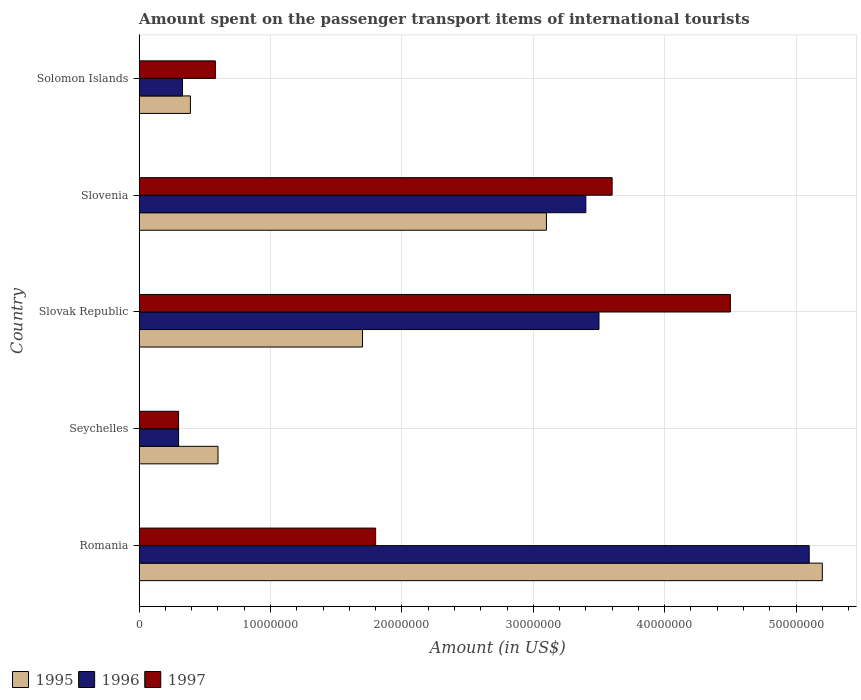How many groups of bars are there?
Offer a terse response. 5. Are the number of bars per tick equal to the number of legend labels?
Your answer should be compact. Yes. Are the number of bars on each tick of the Y-axis equal?
Offer a terse response. Yes. How many bars are there on the 2nd tick from the bottom?
Make the answer very short. 3. What is the label of the 2nd group of bars from the top?
Provide a short and direct response. Slovenia. In how many cases, is the number of bars for a given country not equal to the number of legend labels?
Your answer should be very brief. 0. What is the amount spent on the passenger transport items of international tourists in 1997 in Seychelles?
Ensure brevity in your answer.  3.00e+06. Across all countries, what is the maximum amount spent on the passenger transport items of international tourists in 1996?
Keep it short and to the point. 5.10e+07. Across all countries, what is the minimum amount spent on the passenger transport items of international tourists in 1997?
Ensure brevity in your answer.  3.00e+06. In which country was the amount spent on the passenger transport items of international tourists in 1996 maximum?
Ensure brevity in your answer.  Romania. In which country was the amount spent on the passenger transport items of international tourists in 1995 minimum?
Keep it short and to the point. Solomon Islands. What is the total amount spent on the passenger transport items of international tourists in 1997 in the graph?
Give a very brief answer. 1.08e+08. What is the difference between the amount spent on the passenger transport items of international tourists in 1997 in Slovenia and that in Solomon Islands?
Keep it short and to the point. 3.02e+07. What is the difference between the amount spent on the passenger transport items of international tourists in 1996 in Solomon Islands and the amount spent on the passenger transport items of international tourists in 1997 in Slovenia?
Give a very brief answer. -3.27e+07. What is the average amount spent on the passenger transport items of international tourists in 1997 per country?
Give a very brief answer. 2.16e+07. What is the ratio of the amount spent on the passenger transport items of international tourists in 1995 in Romania to that in Seychelles?
Your answer should be compact. 8.67. Is the difference between the amount spent on the passenger transport items of international tourists in 1997 in Slovak Republic and Slovenia greater than the difference between the amount spent on the passenger transport items of international tourists in 1996 in Slovak Republic and Slovenia?
Your answer should be compact. Yes. What is the difference between the highest and the second highest amount spent on the passenger transport items of international tourists in 1996?
Keep it short and to the point. 1.60e+07. What is the difference between the highest and the lowest amount spent on the passenger transport items of international tourists in 1996?
Provide a succinct answer. 4.80e+07. Is it the case that in every country, the sum of the amount spent on the passenger transport items of international tourists in 1996 and amount spent on the passenger transport items of international tourists in 1995 is greater than the amount spent on the passenger transport items of international tourists in 1997?
Provide a short and direct response. Yes. How many countries are there in the graph?
Offer a very short reply. 5. What is the difference between two consecutive major ticks on the X-axis?
Offer a very short reply. 1.00e+07. Does the graph contain grids?
Keep it short and to the point. Yes. How many legend labels are there?
Your answer should be compact. 3. How are the legend labels stacked?
Your answer should be compact. Horizontal. What is the title of the graph?
Your response must be concise. Amount spent on the passenger transport items of international tourists. What is the Amount (in US$) of 1995 in Romania?
Give a very brief answer. 5.20e+07. What is the Amount (in US$) in 1996 in Romania?
Provide a short and direct response. 5.10e+07. What is the Amount (in US$) of 1997 in Romania?
Your answer should be compact. 1.80e+07. What is the Amount (in US$) of 1997 in Seychelles?
Ensure brevity in your answer.  3.00e+06. What is the Amount (in US$) in 1995 in Slovak Republic?
Make the answer very short. 1.70e+07. What is the Amount (in US$) of 1996 in Slovak Republic?
Provide a succinct answer. 3.50e+07. What is the Amount (in US$) of 1997 in Slovak Republic?
Your answer should be very brief. 4.50e+07. What is the Amount (in US$) of 1995 in Slovenia?
Your answer should be very brief. 3.10e+07. What is the Amount (in US$) of 1996 in Slovenia?
Keep it short and to the point. 3.40e+07. What is the Amount (in US$) of 1997 in Slovenia?
Your answer should be compact. 3.60e+07. What is the Amount (in US$) in 1995 in Solomon Islands?
Provide a short and direct response. 3.90e+06. What is the Amount (in US$) in 1996 in Solomon Islands?
Your response must be concise. 3.30e+06. What is the Amount (in US$) in 1997 in Solomon Islands?
Offer a terse response. 5.80e+06. Across all countries, what is the maximum Amount (in US$) of 1995?
Provide a succinct answer. 5.20e+07. Across all countries, what is the maximum Amount (in US$) in 1996?
Provide a short and direct response. 5.10e+07. Across all countries, what is the maximum Amount (in US$) in 1997?
Your answer should be compact. 4.50e+07. Across all countries, what is the minimum Amount (in US$) in 1995?
Your answer should be compact. 3.90e+06. Across all countries, what is the minimum Amount (in US$) of 1996?
Ensure brevity in your answer.  3.00e+06. Across all countries, what is the minimum Amount (in US$) of 1997?
Offer a very short reply. 3.00e+06. What is the total Amount (in US$) in 1995 in the graph?
Give a very brief answer. 1.10e+08. What is the total Amount (in US$) of 1996 in the graph?
Keep it short and to the point. 1.26e+08. What is the total Amount (in US$) of 1997 in the graph?
Your answer should be compact. 1.08e+08. What is the difference between the Amount (in US$) in 1995 in Romania and that in Seychelles?
Provide a succinct answer. 4.60e+07. What is the difference between the Amount (in US$) of 1996 in Romania and that in Seychelles?
Ensure brevity in your answer.  4.80e+07. What is the difference between the Amount (in US$) in 1997 in Romania and that in Seychelles?
Keep it short and to the point. 1.50e+07. What is the difference between the Amount (in US$) in 1995 in Romania and that in Slovak Republic?
Your answer should be very brief. 3.50e+07. What is the difference between the Amount (in US$) in 1996 in Romania and that in Slovak Republic?
Offer a very short reply. 1.60e+07. What is the difference between the Amount (in US$) of 1997 in Romania and that in Slovak Republic?
Ensure brevity in your answer.  -2.70e+07. What is the difference between the Amount (in US$) of 1995 in Romania and that in Slovenia?
Offer a very short reply. 2.10e+07. What is the difference between the Amount (in US$) of 1996 in Romania and that in Slovenia?
Your answer should be compact. 1.70e+07. What is the difference between the Amount (in US$) of 1997 in Romania and that in Slovenia?
Your response must be concise. -1.80e+07. What is the difference between the Amount (in US$) of 1995 in Romania and that in Solomon Islands?
Your answer should be compact. 4.81e+07. What is the difference between the Amount (in US$) in 1996 in Romania and that in Solomon Islands?
Your answer should be very brief. 4.77e+07. What is the difference between the Amount (in US$) of 1997 in Romania and that in Solomon Islands?
Your answer should be compact. 1.22e+07. What is the difference between the Amount (in US$) in 1995 in Seychelles and that in Slovak Republic?
Your response must be concise. -1.10e+07. What is the difference between the Amount (in US$) in 1996 in Seychelles and that in Slovak Republic?
Your answer should be compact. -3.20e+07. What is the difference between the Amount (in US$) in 1997 in Seychelles and that in Slovak Republic?
Give a very brief answer. -4.20e+07. What is the difference between the Amount (in US$) in 1995 in Seychelles and that in Slovenia?
Keep it short and to the point. -2.50e+07. What is the difference between the Amount (in US$) in 1996 in Seychelles and that in Slovenia?
Offer a terse response. -3.10e+07. What is the difference between the Amount (in US$) of 1997 in Seychelles and that in Slovenia?
Your answer should be compact. -3.30e+07. What is the difference between the Amount (in US$) in 1995 in Seychelles and that in Solomon Islands?
Give a very brief answer. 2.10e+06. What is the difference between the Amount (in US$) of 1997 in Seychelles and that in Solomon Islands?
Make the answer very short. -2.80e+06. What is the difference between the Amount (in US$) of 1995 in Slovak Republic and that in Slovenia?
Provide a short and direct response. -1.40e+07. What is the difference between the Amount (in US$) in 1997 in Slovak Republic and that in Slovenia?
Your answer should be compact. 9.00e+06. What is the difference between the Amount (in US$) of 1995 in Slovak Republic and that in Solomon Islands?
Give a very brief answer. 1.31e+07. What is the difference between the Amount (in US$) in 1996 in Slovak Republic and that in Solomon Islands?
Your answer should be very brief. 3.17e+07. What is the difference between the Amount (in US$) of 1997 in Slovak Republic and that in Solomon Islands?
Your response must be concise. 3.92e+07. What is the difference between the Amount (in US$) of 1995 in Slovenia and that in Solomon Islands?
Your answer should be compact. 2.71e+07. What is the difference between the Amount (in US$) of 1996 in Slovenia and that in Solomon Islands?
Offer a terse response. 3.07e+07. What is the difference between the Amount (in US$) in 1997 in Slovenia and that in Solomon Islands?
Ensure brevity in your answer.  3.02e+07. What is the difference between the Amount (in US$) in 1995 in Romania and the Amount (in US$) in 1996 in Seychelles?
Offer a terse response. 4.90e+07. What is the difference between the Amount (in US$) in 1995 in Romania and the Amount (in US$) in 1997 in Seychelles?
Provide a short and direct response. 4.90e+07. What is the difference between the Amount (in US$) in 1996 in Romania and the Amount (in US$) in 1997 in Seychelles?
Keep it short and to the point. 4.80e+07. What is the difference between the Amount (in US$) of 1995 in Romania and the Amount (in US$) of 1996 in Slovak Republic?
Give a very brief answer. 1.70e+07. What is the difference between the Amount (in US$) of 1995 in Romania and the Amount (in US$) of 1996 in Slovenia?
Offer a terse response. 1.80e+07. What is the difference between the Amount (in US$) of 1995 in Romania and the Amount (in US$) of 1997 in Slovenia?
Make the answer very short. 1.60e+07. What is the difference between the Amount (in US$) of 1996 in Romania and the Amount (in US$) of 1997 in Slovenia?
Your response must be concise. 1.50e+07. What is the difference between the Amount (in US$) of 1995 in Romania and the Amount (in US$) of 1996 in Solomon Islands?
Offer a very short reply. 4.87e+07. What is the difference between the Amount (in US$) in 1995 in Romania and the Amount (in US$) in 1997 in Solomon Islands?
Provide a short and direct response. 4.62e+07. What is the difference between the Amount (in US$) of 1996 in Romania and the Amount (in US$) of 1997 in Solomon Islands?
Give a very brief answer. 4.52e+07. What is the difference between the Amount (in US$) of 1995 in Seychelles and the Amount (in US$) of 1996 in Slovak Republic?
Provide a short and direct response. -2.90e+07. What is the difference between the Amount (in US$) of 1995 in Seychelles and the Amount (in US$) of 1997 in Slovak Republic?
Provide a succinct answer. -3.90e+07. What is the difference between the Amount (in US$) in 1996 in Seychelles and the Amount (in US$) in 1997 in Slovak Republic?
Your answer should be compact. -4.20e+07. What is the difference between the Amount (in US$) in 1995 in Seychelles and the Amount (in US$) in 1996 in Slovenia?
Make the answer very short. -2.80e+07. What is the difference between the Amount (in US$) in 1995 in Seychelles and the Amount (in US$) in 1997 in Slovenia?
Offer a very short reply. -3.00e+07. What is the difference between the Amount (in US$) in 1996 in Seychelles and the Amount (in US$) in 1997 in Slovenia?
Provide a short and direct response. -3.30e+07. What is the difference between the Amount (in US$) in 1995 in Seychelles and the Amount (in US$) in 1996 in Solomon Islands?
Give a very brief answer. 2.70e+06. What is the difference between the Amount (in US$) in 1996 in Seychelles and the Amount (in US$) in 1997 in Solomon Islands?
Offer a terse response. -2.80e+06. What is the difference between the Amount (in US$) of 1995 in Slovak Republic and the Amount (in US$) of 1996 in Slovenia?
Provide a short and direct response. -1.70e+07. What is the difference between the Amount (in US$) of 1995 in Slovak Republic and the Amount (in US$) of 1997 in Slovenia?
Provide a succinct answer. -1.90e+07. What is the difference between the Amount (in US$) of 1996 in Slovak Republic and the Amount (in US$) of 1997 in Slovenia?
Make the answer very short. -1.00e+06. What is the difference between the Amount (in US$) of 1995 in Slovak Republic and the Amount (in US$) of 1996 in Solomon Islands?
Keep it short and to the point. 1.37e+07. What is the difference between the Amount (in US$) in 1995 in Slovak Republic and the Amount (in US$) in 1997 in Solomon Islands?
Keep it short and to the point. 1.12e+07. What is the difference between the Amount (in US$) in 1996 in Slovak Republic and the Amount (in US$) in 1997 in Solomon Islands?
Provide a succinct answer. 2.92e+07. What is the difference between the Amount (in US$) in 1995 in Slovenia and the Amount (in US$) in 1996 in Solomon Islands?
Provide a short and direct response. 2.77e+07. What is the difference between the Amount (in US$) in 1995 in Slovenia and the Amount (in US$) in 1997 in Solomon Islands?
Make the answer very short. 2.52e+07. What is the difference between the Amount (in US$) in 1996 in Slovenia and the Amount (in US$) in 1997 in Solomon Islands?
Your answer should be very brief. 2.82e+07. What is the average Amount (in US$) of 1995 per country?
Keep it short and to the point. 2.20e+07. What is the average Amount (in US$) in 1996 per country?
Offer a terse response. 2.53e+07. What is the average Amount (in US$) of 1997 per country?
Your answer should be very brief. 2.16e+07. What is the difference between the Amount (in US$) of 1995 and Amount (in US$) of 1996 in Romania?
Offer a very short reply. 1.00e+06. What is the difference between the Amount (in US$) in 1995 and Amount (in US$) in 1997 in Romania?
Give a very brief answer. 3.40e+07. What is the difference between the Amount (in US$) in 1996 and Amount (in US$) in 1997 in Romania?
Offer a very short reply. 3.30e+07. What is the difference between the Amount (in US$) of 1995 and Amount (in US$) of 1996 in Seychelles?
Ensure brevity in your answer.  3.00e+06. What is the difference between the Amount (in US$) in 1995 and Amount (in US$) in 1997 in Seychelles?
Offer a very short reply. 3.00e+06. What is the difference between the Amount (in US$) of 1995 and Amount (in US$) of 1996 in Slovak Republic?
Your answer should be compact. -1.80e+07. What is the difference between the Amount (in US$) in 1995 and Amount (in US$) in 1997 in Slovak Republic?
Your response must be concise. -2.80e+07. What is the difference between the Amount (in US$) in 1996 and Amount (in US$) in 1997 in Slovak Republic?
Your answer should be compact. -1.00e+07. What is the difference between the Amount (in US$) in 1995 and Amount (in US$) in 1997 in Slovenia?
Give a very brief answer. -5.00e+06. What is the difference between the Amount (in US$) in 1996 and Amount (in US$) in 1997 in Slovenia?
Your answer should be compact. -2.00e+06. What is the difference between the Amount (in US$) of 1995 and Amount (in US$) of 1996 in Solomon Islands?
Make the answer very short. 6.00e+05. What is the difference between the Amount (in US$) of 1995 and Amount (in US$) of 1997 in Solomon Islands?
Your answer should be compact. -1.90e+06. What is the difference between the Amount (in US$) of 1996 and Amount (in US$) of 1997 in Solomon Islands?
Provide a succinct answer. -2.50e+06. What is the ratio of the Amount (in US$) in 1995 in Romania to that in Seychelles?
Ensure brevity in your answer.  8.67. What is the ratio of the Amount (in US$) in 1996 in Romania to that in Seychelles?
Provide a succinct answer. 17. What is the ratio of the Amount (in US$) of 1997 in Romania to that in Seychelles?
Give a very brief answer. 6. What is the ratio of the Amount (in US$) in 1995 in Romania to that in Slovak Republic?
Make the answer very short. 3.06. What is the ratio of the Amount (in US$) of 1996 in Romania to that in Slovak Republic?
Ensure brevity in your answer.  1.46. What is the ratio of the Amount (in US$) in 1997 in Romania to that in Slovak Republic?
Offer a terse response. 0.4. What is the ratio of the Amount (in US$) of 1995 in Romania to that in Slovenia?
Give a very brief answer. 1.68. What is the ratio of the Amount (in US$) in 1996 in Romania to that in Slovenia?
Provide a succinct answer. 1.5. What is the ratio of the Amount (in US$) of 1997 in Romania to that in Slovenia?
Offer a terse response. 0.5. What is the ratio of the Amount (in US$) of 1995 in Romania to that in Solomon Islands?
Your answer should be compact. 13.33. What is the ratio of the Amount (in US$) in 1996 in Romania to that in Solomon Islands?
Ensure brevity in your answer.  15.45. What is the ratio of the Amount (in US$) in 1997 in Romania to that in Solomon Islands?
Give a very brief answer. 3.1. What is the ratio of the Amount (in US$) in 1995 in Seychelles to that in Slovak Republic?
Make the answer very short. 0.35. What is the ratio of the Amount (in US$) in 1996 in Seychelles to that in Slovak Republic?
Ensure brevity in your answer.  0.09. What is the ratio of the Amount (in US$) of 1997 in Seychelles to that in Slovak Republic?
Your answer should be compact. 0.07. What is the ratio of the Amount (in US$) in 1995 in Seychelles to that in Slovenia?
Your answer should be compact. 0.19. What is the ratio of the Amount (in US$) in 1996 in Seychelles to that in Slovenia?
Give a very brief answer. 0.09. What is the ratio of the Amount (in US$) of 1997 in Seychelles to that in Slovenia?
Your answer should be compact. 0.08. What is the ratio of the Amount (in US$) of 1995 in Seychelles to that in Solomon Islands?
Provide a succinct answer. 1.54. What is the ratio of the Amount (in US$) of 1996 in Seychelles to that in Solomon Islands?
Ensure brevity in your answer.  0.91. What is the ratio of the Amount (in US$) of 1997 in Seychelles to that in Solomon Islands?
Your response must be concise. 0.52. What is the ratio of the Amount (in US$) of 1995 in Slovak Republic to that in Slovenia?
Give a very brief answer. 0.55. What is the ratio of the Amount (in US$) of 1996 in Slovak Republic to that in Slovenia?
Your answer should be compact. 1.03. What is the ratio of the Amount (in US$) of 1997 in Slovak Republic to that in Slovenia?
Ensure brevity in your answer.  1.25. What is the ratio of the Amount (in US$) of 1995 in Slovak Republic to that in Solomon Islands?
Give a very brief answer. 4.36. What is the ratio of the Amount (in US$) in 1996 in Slovak Republic to that in Solomon Islands?
Make the answer very short. 10.61. What is the ratio of the Amount (in US$) of 1997 in Slovak Republic to that in Solomon Islands?
Give a very brief answer. 7.76. What is the ratio of the Amount (in US$) in 1995 in Slovenia to that in Solomon Islands?
Ensure brevity in your answer.  7.95. What is the ratio of the Amount (in US$) of 1996 in Slovenia to that in Solomon Islands?
Offer a terse response. 10.3. What is the ratio of the Amount (in US$) of 1997 in Slovenia to that in Solomon Islands?
Your answer should be compact. 6.21. What is the difference between the highest and the second highest Amount (in US$) of 1995?
Offer a very short reply. 2.10e+07. What is the difference between the highest and the second highest Amount (in US$) of 1996?
Your answer should be compact. 1.60e+07. What is the difference between the highest and the second highest Amount (in US$) in 1997?
Offer a very short reply. 9.00e+06. What is the difference between the highest and the lowest Amount (in US$) in 1995?
Give a very brief answer. 4.81e+07. What is the difference between the highest and the lowest Amount (in US$) of 1996?
Your answer should be very brief. 4.80e+07. What is the difference between the highest and the lowest Amount (in US$) in 1997?
Provide a succinct answer. 4.20e+07. 